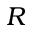Convert formula to latex. <formula><loc_0><loc_0><loc_500><loc_500>R</formula> 